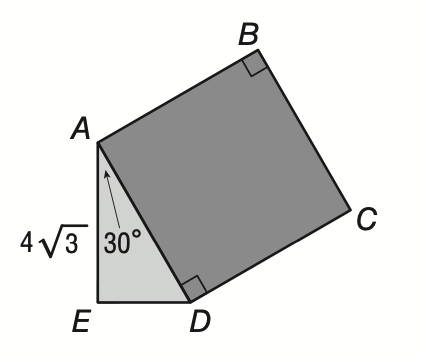Question: In the figure, below, square A B C D is attached to \triangle A D E as shown. If m \angle E A D is 30 and A E is equal to 4 \sqrt { 3 }, then what is the area of square A B C D?
Choices:
A. 8 \sqrt 3
B. 16
C. 64
D. 64 \sqrt 2
Answer with the letter. Answer: C 